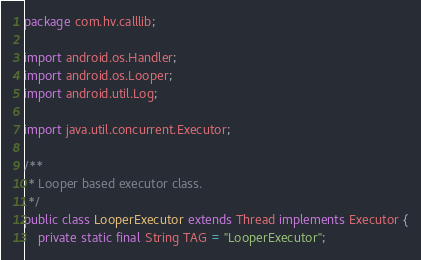<code> <loc_0><loc_0><loc_500><loc_500><_Java_>
package com.hv.calllib;

import android.os.Handler;
import android.os.Looper;
import android.util.Log;

import java.util.concurrent.Executor;

/**
 * Looper based executor class.
 */
public class LooperExecutor extends Thread implements Executor {
    private static final String TAG = "LooperExecutor";</code> 